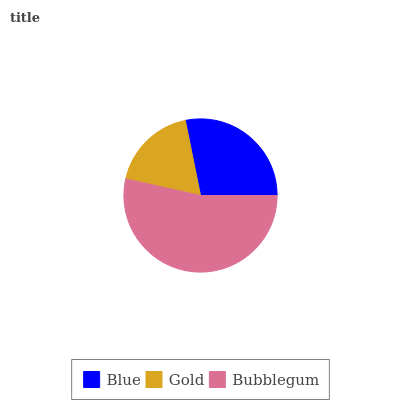Is Gold the minimum?
Answer yes or no. Yes. Is Bubblegum the maximum?
Answer yes or no. Yes. Is Bubblegum the minimum?
Answer yes or no. No. Is Gold the maximum?
Answer yes or no. No. Is Bubblegum greater than Gold?
Answer yes or no. Yes. Is Gold less than Bubblegum?
Answer yes or no. Yes. Is Gold greater than Bubblegum?
Answer yes or no. No. Is Bubblegum less than Gold?
Answer yes or no. No. Is Blue the high median?
Answer yes or no. Yes. Is Blue the low median?
Answer yes or no. Yes. Is Gold the high median?
Answer yes or no. No. Is Bubblegum the low median?
Answer yes or no. No. 